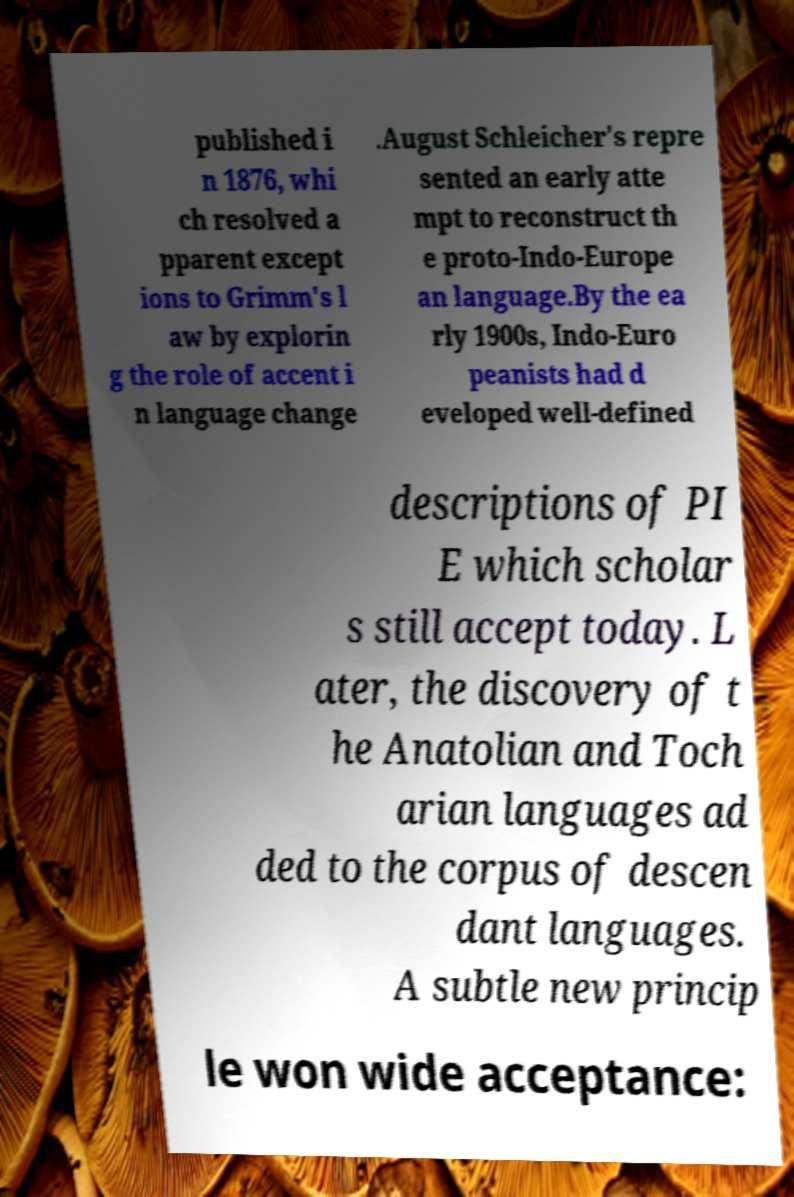Can you accurately transcribe the text from the provided image for me? published i n 1876, whi ch resolved a pparent except ions to Grimm's l aw by explorin g the role of accent i n language change .August Schleicher's repre sented an early atte mpt to reconstruct th e proto-Indo-Europe an language.By the ea rly 1900s, Indo-Euro peanists had d eveloped well-defined descriptions of PI E which scholar s still accept today. L ater, the discovery of t he Anatolian and Toch arian languages ad ded to the corpus of descen dant languages. A subtle new princip le won wide acceptance: 